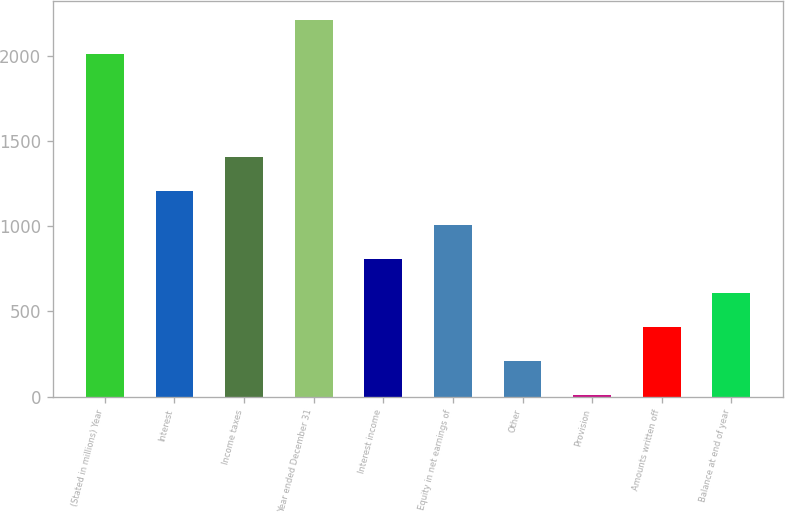Convert chart to OTSL. <chart><loc_0><loc_0><loc_500><loc_500><bar_chart><fcel>(Stated in millions) Year<fcel>Interest<fcel>Income taxes<fcel>Year ended December 31<fcel>Interest income<fcel>Equity in net earnings of<fcel>Other<fcel>Provision<fcel>Amounts written off<fcel>Balance at end of year<nl><fcel>2007<fcel>1207.8<fcel>1407.6<fcel>2206.8<fcel>808.2<fcel>1008<fcel>208.8<fcel>9<fcel>408.6<fcel>608.4<nl></chart> 